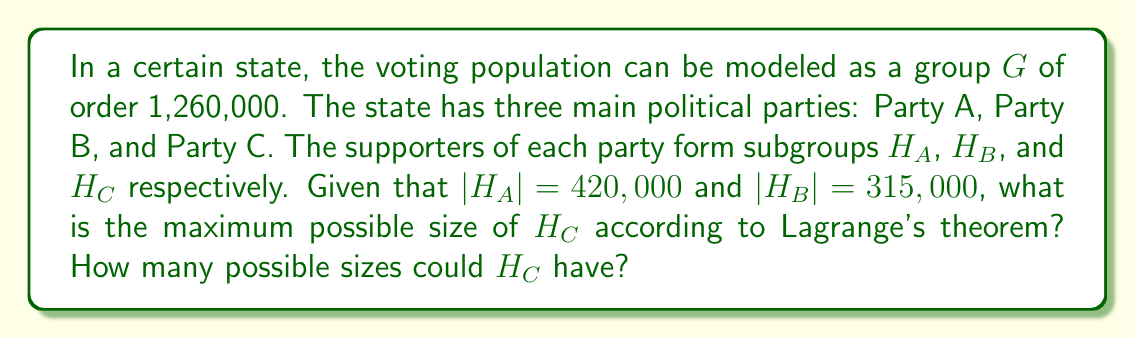Could you help me with this problem? To solve this problem, we'll apply Lagrange's theorem and consider the implications for subgroup structures in demographic voting blocs.

1) Lagrange's theorem states that for any finite group $G$ and any subgroup $H$ of $G$, the order of $H$ divides the order of $G$. In other words, $|G| = |H| \cdot [G:H]$, where $[G:H]$ is the index of $H$ in $G$.

2) Given:
   $|G| = 1,260,000$
   $|H_A| = 420,000$
   $|H_B| = 315,000$

3) First, let's verify that $H_A$ and $H_B$ satisfy Lagrange's theorem:
   $1,260,000 \div 420,000 = 3$ (integer)
   $1,260,000 \div 315,000 = 4$ (integer)

4) Now, to find the possible sizes of $H_C$, we need to find the divisors of 1,260,000.

5) Prime factorization of 1,260,000:
   $1,260,000 = 2^6 \times 3^2 \times 5^3 \times 7$

6) The divisors of 1,260,000 are all numbers of the form:
   $2^a \times 3^b \times 5^c \times 7^d$
   where $0 \leq a \leq 6$, $0 \leq b \leq 2$, $0 \leq c \leq 3$, and $0 \leq d \leq 1$

7) The total number of divisors is:
   $(6+1) \times (2+1) \times (3+1) \times (1+1) = 7 \times 3 \times 4 \times 2 = 168$

8) The maximum possible size of $H_C$ would be the largest proper divisor of 1,260,000, which is 630,000.

Therefore, the maximum possible size of $H_C$ is 630,000, and there are 168 possible sizes for $H_C$ according to Lagrange's theorem.
Answer: The maximum possible size of $H_C$ is 630,000, and there are 168 possible sizes for $H_C$. 